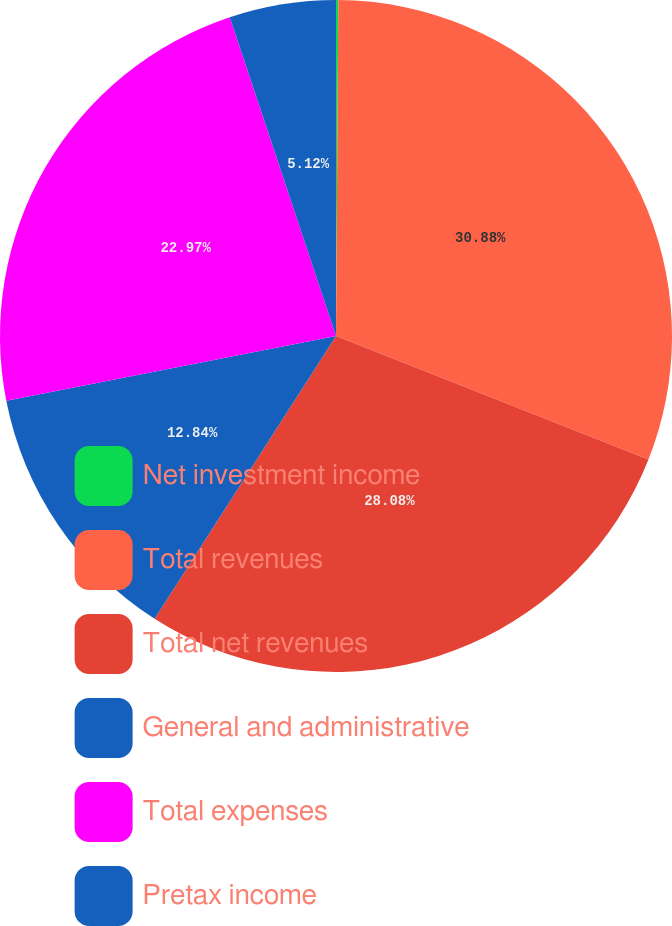Convert chart to OTSL. <chart><loc_0><loc_0><loc_500><loc_500><pie_chart><fcel>Net investment income<fcel>Total revenues<fcel>Total net revenues<fcel>General and administrative<fcel>Total expenses<fcel>Pretax income<nl><fcel>0.11%<fcel>30.89%<fcel>28.09%<fcel>12.84%<fcel>22.97%<fcel>5.12%<nl></chart> 